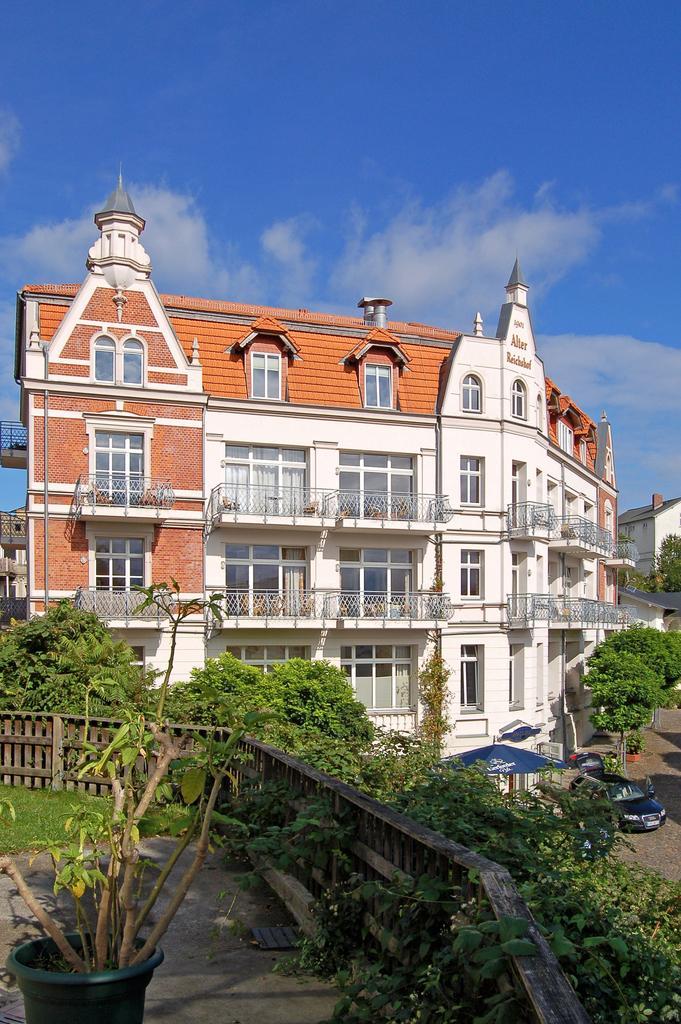How would you summarize this image in a sentence or two? In the middle it's a big house in white color. On the right side few vehicles are parked at here and these are the trees. At the top it's a blue color sky. 